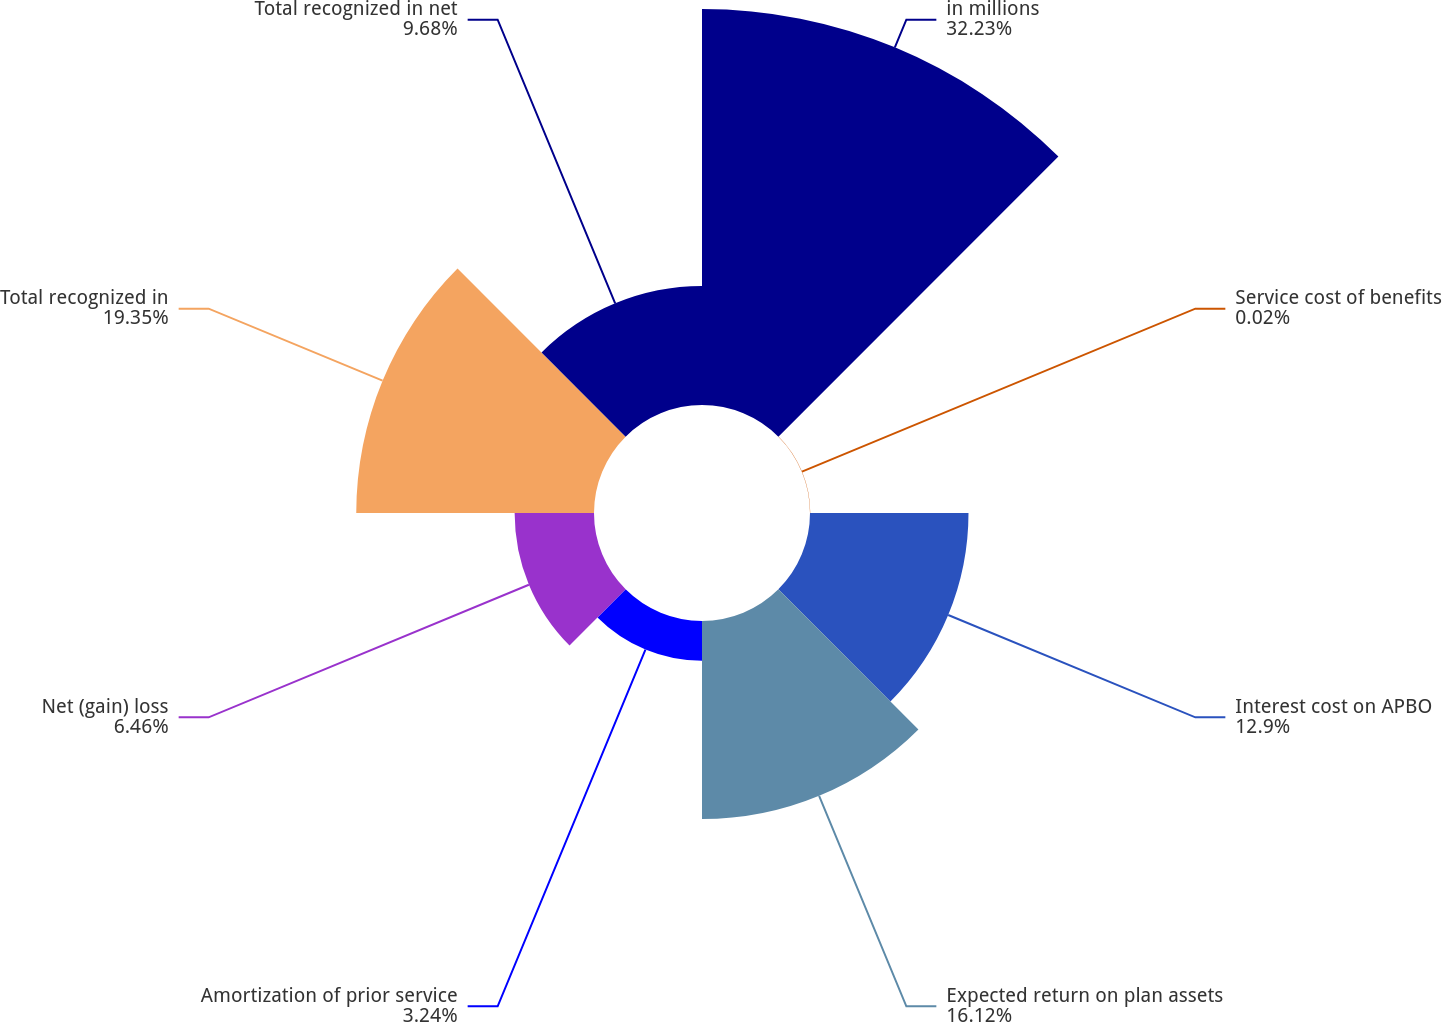Convert chart to OTSL. <chart><loc_0><loc_0><loc_500><loc_500><pie_chart><fcel>in millions<fcel>Service cost of benefits<fcel>Interest cost on APBO<fcel>Expected return on plan assets<fcel>Amortization of prior service<fcel>Net (gain) loss<fcel>Total recognized in<fcel>Total recognized in net<nl><fcel>32.23%<fcel>0.02%<fcel>12.9%<fcel>16.12%<fcel>3.24%<fcel>6.46%<fcel>19.35%<fcel>9.68%<nl></chart> 